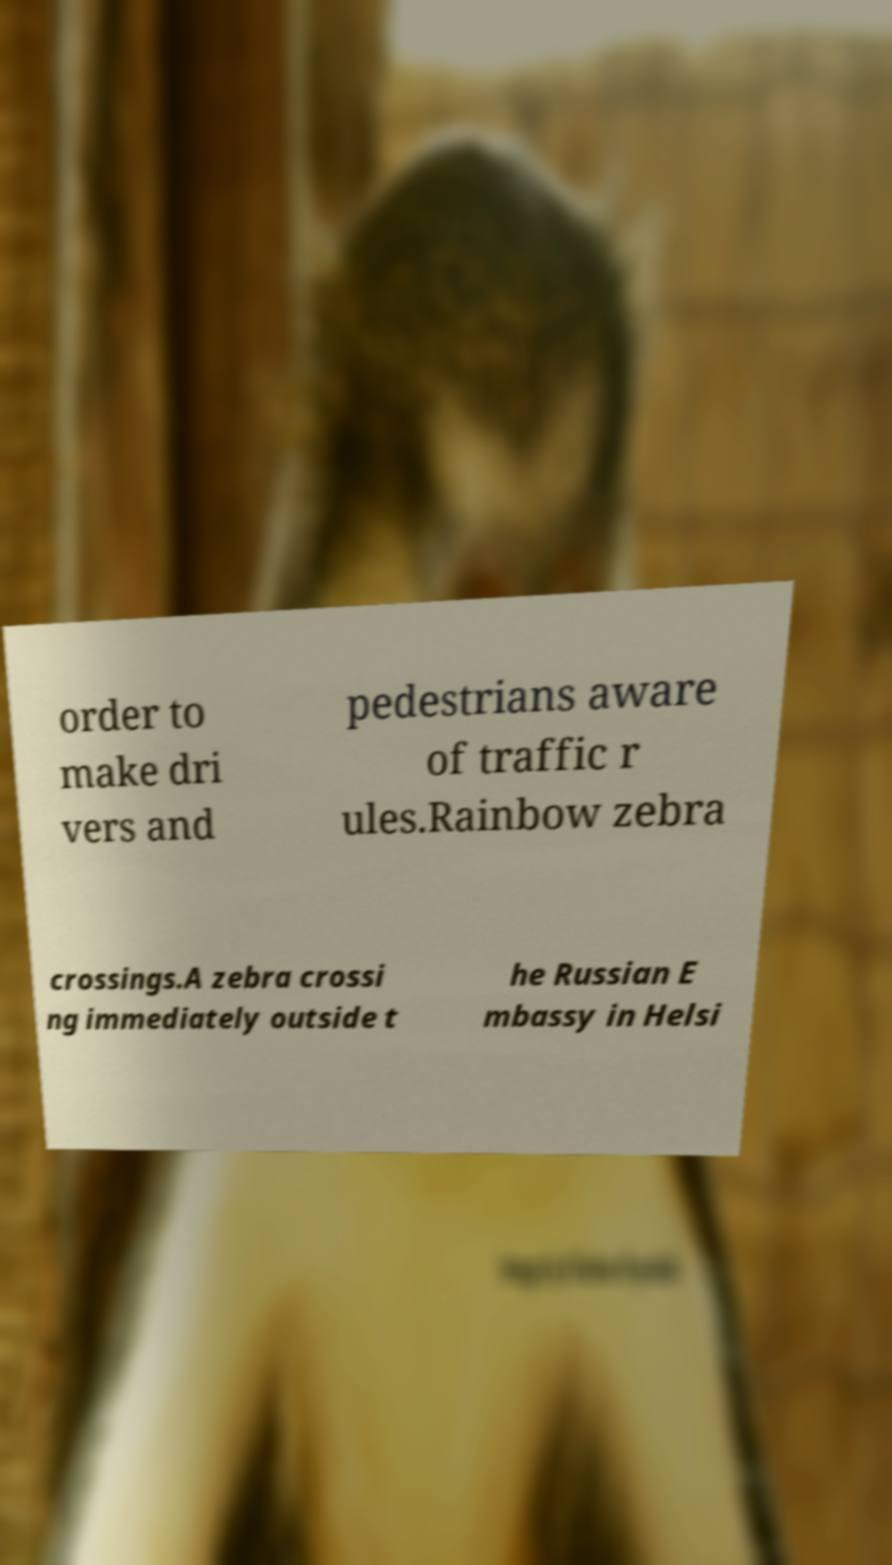I need the written content from this picture converted into text. Can you do that? order to make dri vers and pedestrians aware of traffic r ules.Rainbow zebra crossings.A zebra crossi ng immediately outside t he Russian E mbassy in Helsi 